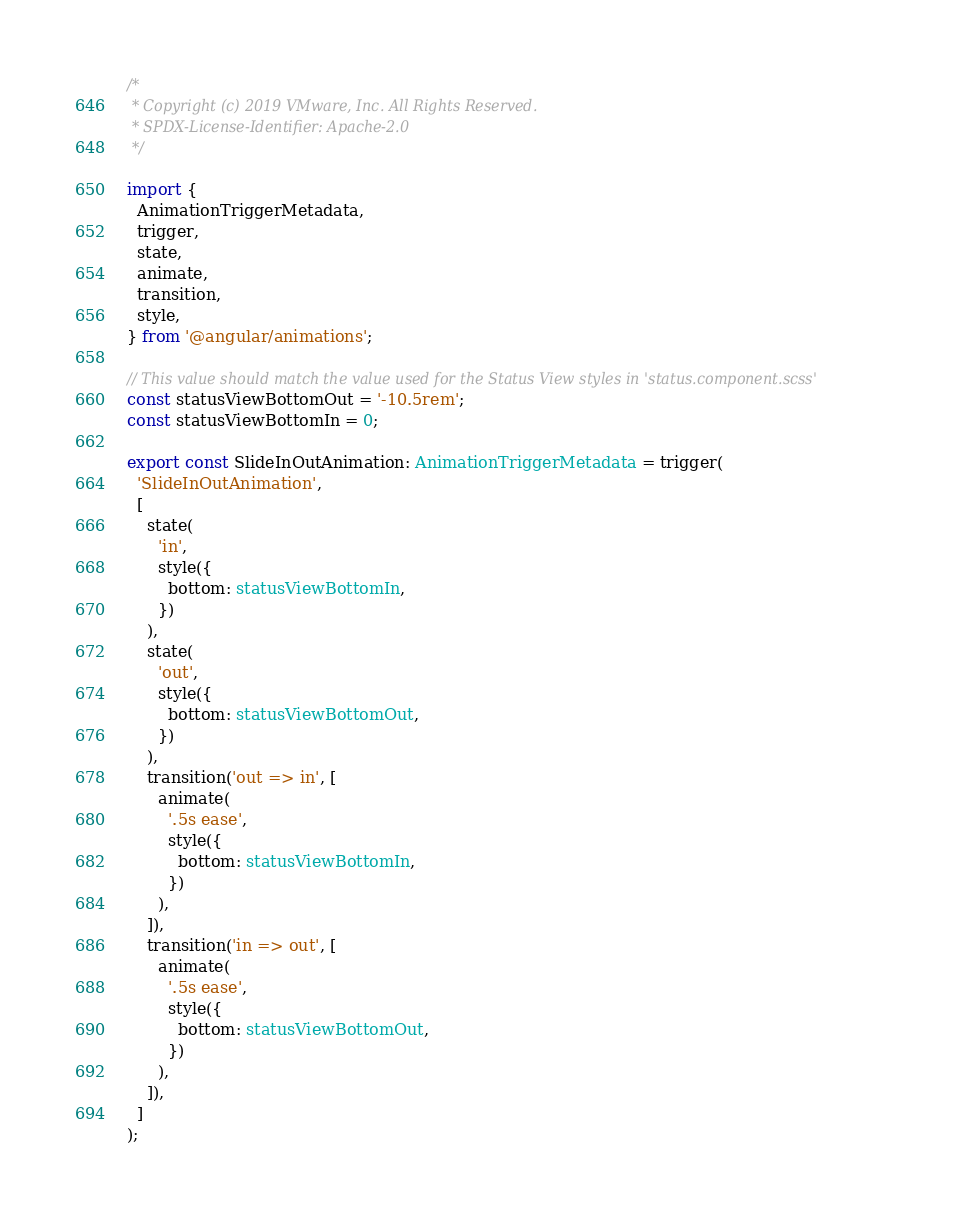<code> <loc_0><loc_0><loc_500><loc_500><_TypeScript_>/*
 * Copyright (c) 2019 VMware, Inc. All Rights Reserved.
 * SPDX-License-Identifier: Apache-2.0
 */

import {
  AnimationTriggerMetadata,
  trigger,
  state,
  animate,
  transition,
  style,
} from '@angular/animations';

// This value should match the value used for the Status View styles in 'status.component.scss'
const statusViewBottomOut = '-10.5rem';
const statusViewBottomIn = 0;

export const SlideInOutAnimation: AnimationTriggerMetadata = trigger(
  'SlideInOutAnimation',
  [
    state(
      'in',
      style({
        bottom: statusViewBottomIn,
      })
    ),
    state(
      'out',
      style({
        bottom: statusViewBottomOut,
      })
    ),
    transition('out => in', [
      animate(
        '.5s ease',
        style({
          bottom: statusViewBottomIn,
        })
      ),
    ]),
    transition('in => out', [
      animate(
        '.5s ease',
        style({
          bottom: statusViewBottomOut,
        })
      ),
    ]),
  ]
);
</code> 